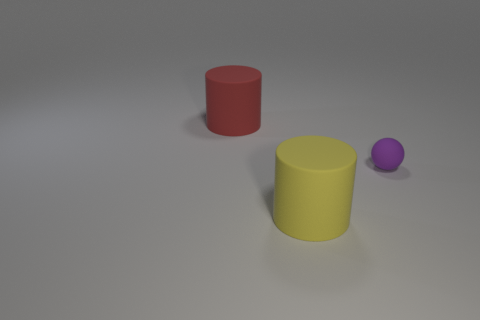How many things are either matte objects or tiny matte balls behind the yellow rubber object?
Your response must be concise. 3. How many red objects are behind the big object to the left of the matte thing in front of the tiny purple object?
Offer a terse response. 0. The tiny thing that is made of the same material as the big yellow object is what color?
Offer a very short reply. Purple. Does the rubber thing that is in front of the rubber ball have the same size as the tiny purple ball?
Offer a very short reply. No. How many objects are large red matte things or big blue things?
Your response must be concise. 1. The thing in front of the tiny sphere that is behind the large matte cylinder that is in front of the red matte cylinder is made of what material?
Offer a terse response. Rubber. What is the big cylinder in front of the red rubber object made of?
Provide a short and direct response. Rubber. Are there any yellow matte things that have the same size as the purple object?
Your answer should be very brief. No. Is the color of the big cylinder that is behind the tiny matte sphere the same as the ball?
Offer a terse response. No. How many cyan objects are big cylinders or tiny matte spheres?
Your response must be concise. 0. 